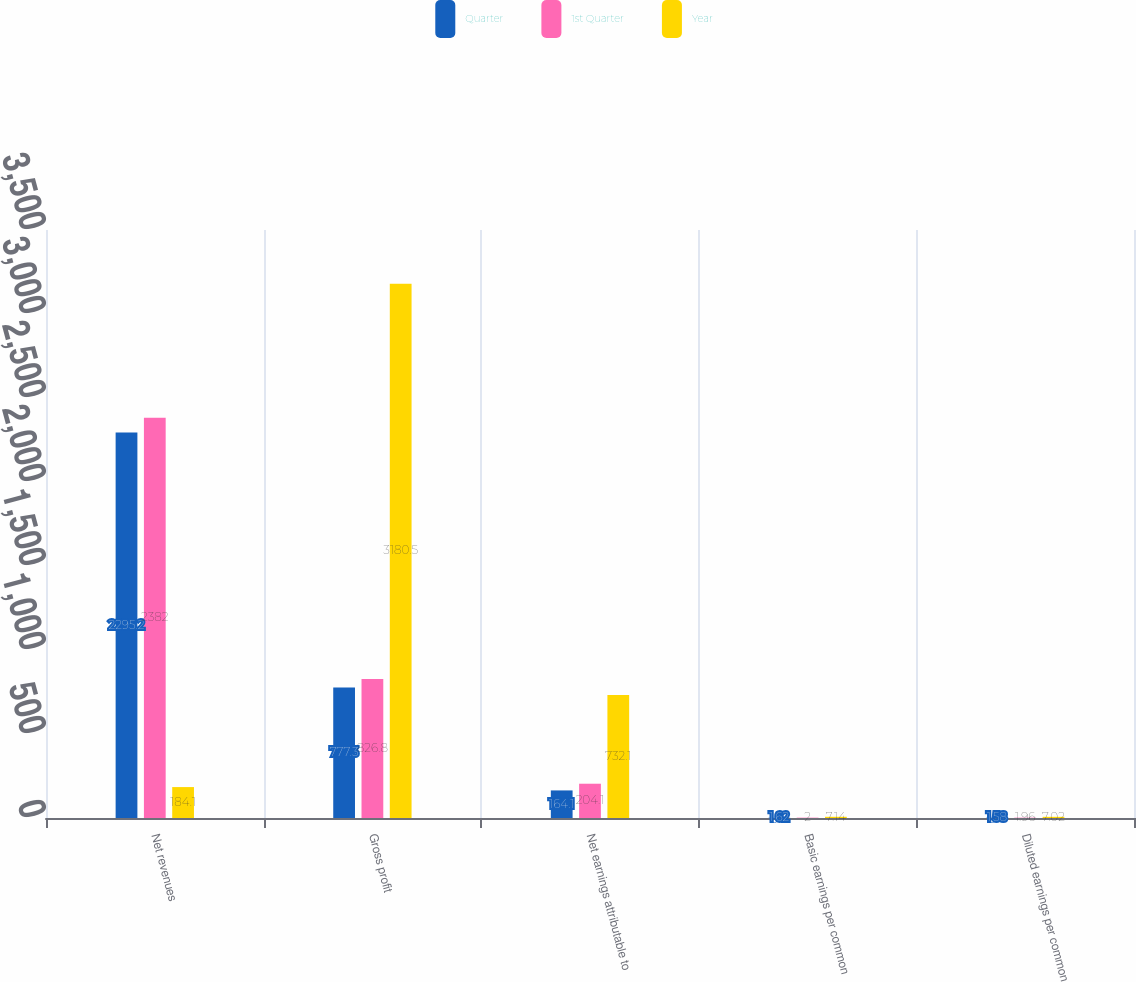Convert chart to OTSL. <chart><loc_0><loc_0><loc_500><loc_500><stacked_bar_chart><ecel><fcel>Net revenues<fcel>Gross profit<fcel>Net earnings attributable to<fcel>Basic earnings per common<fcel>Diluted earnings per common<nl><fcel>Quarter<fcel>2295.2<fcel>777.3<fcel>164.1<fcel>1.62<fcel>1.58<nl><fcel>1st Quarter<fcel>2382<fcel>826.8<fcel>204.1<fcel>2<fcel>1.96<nl><fcel>Year<fcel>184.1<fcel>3180.5<fcel>732.1<fcel>7.14<fcel>7.02<nl></chart> 